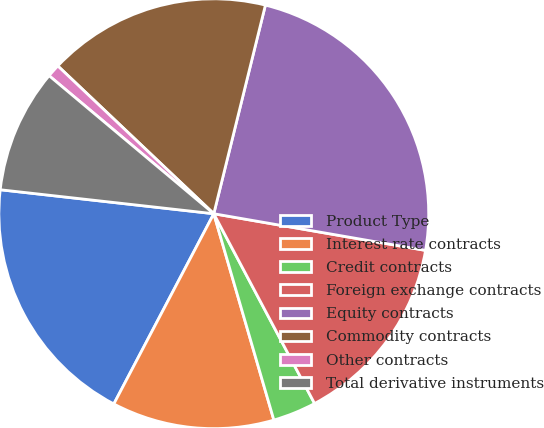<chart> <loc_0><loc_0><loc_500><loc_500><pie_chart><fcel>Product Type<fcel>Interest rate contracts<fcel>Credit contracts<fcel>Foreign exchange contracts<fcel>Equity contracts<fcel>Commodity contracts<fcel>Other contracts<fcel>Total derivative instruments<nl><fcel>19.08%<fcel>12.21%<fcel>3.26%<fcel>14.5%<fcel>23.87%<fcel>16.79%<fcel>0.97%<fcel>9.32%<nl></chart> 